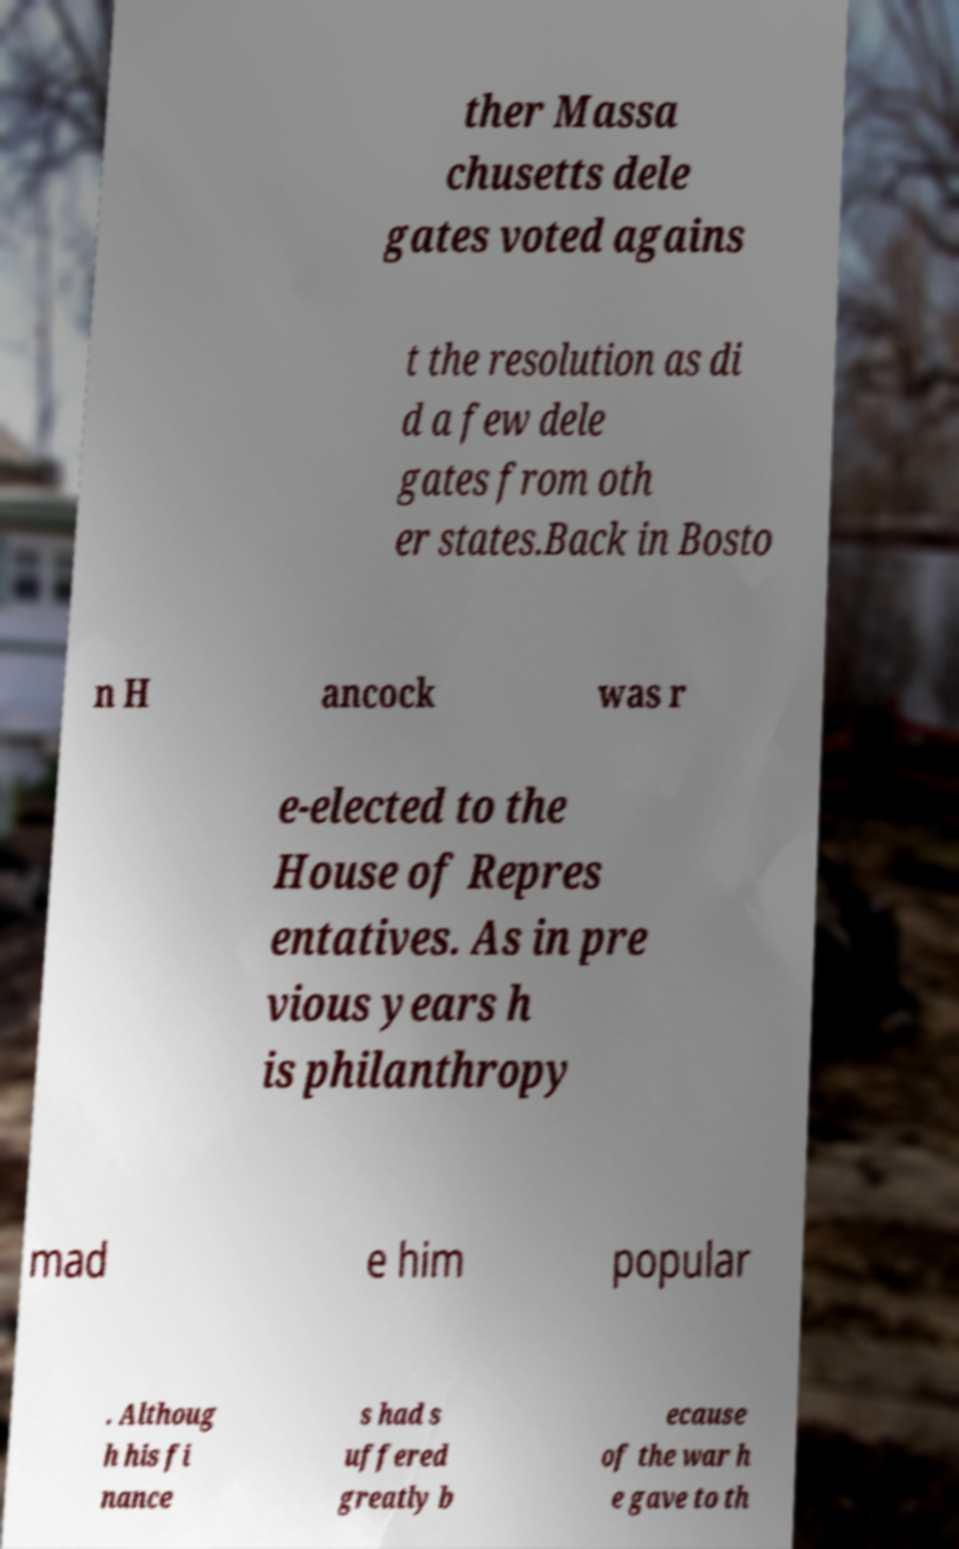I need the written content from this picture converted into text. Can you do that? ther Massa chusetts dele gates voted agains t the resolution as di d a few dele gates from oth er states.Back in Bosto n H ancock was r e-elected to the House of Repres entatives. As in pre vious years h is philanthropy mad e him popular . Althoug h his fi nance s had s uffered greatly b ecause of the war h e gave to th 